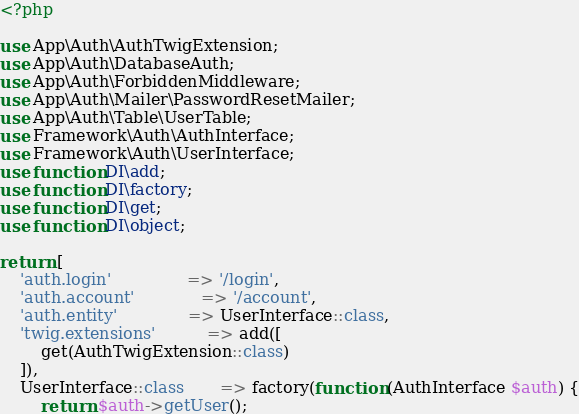<code> <loc_0><loc_0><loc_500><loc_500><_PHP_><?php

use App\Auth\AuthTwigExtension;
use App\Auth\DatabaseAuth;
use App\Auth\ForbiddenMiddleware;
use App\Auth\Mailer\PasswordResetMailer;
use App\Auth\Table\UserTable;
use Framework\Auth\AuthInterface;
use Framework\Auth\UserInterface;
use function DI\add;
use function DI\factory;
use function DI\get;
use function DI\object;

return [
    'auth.login'               => '/login',
    'auth.account'             => '/account',
    'auth.entity'              => UserInterface::class,
    'twig.extensions'          => add([
        get(AuthTwigExtension::class)
    ]),
    UserInterface::class       => factory(function (AuthInterface $auth) {
        return $auth->getUser();</code> 